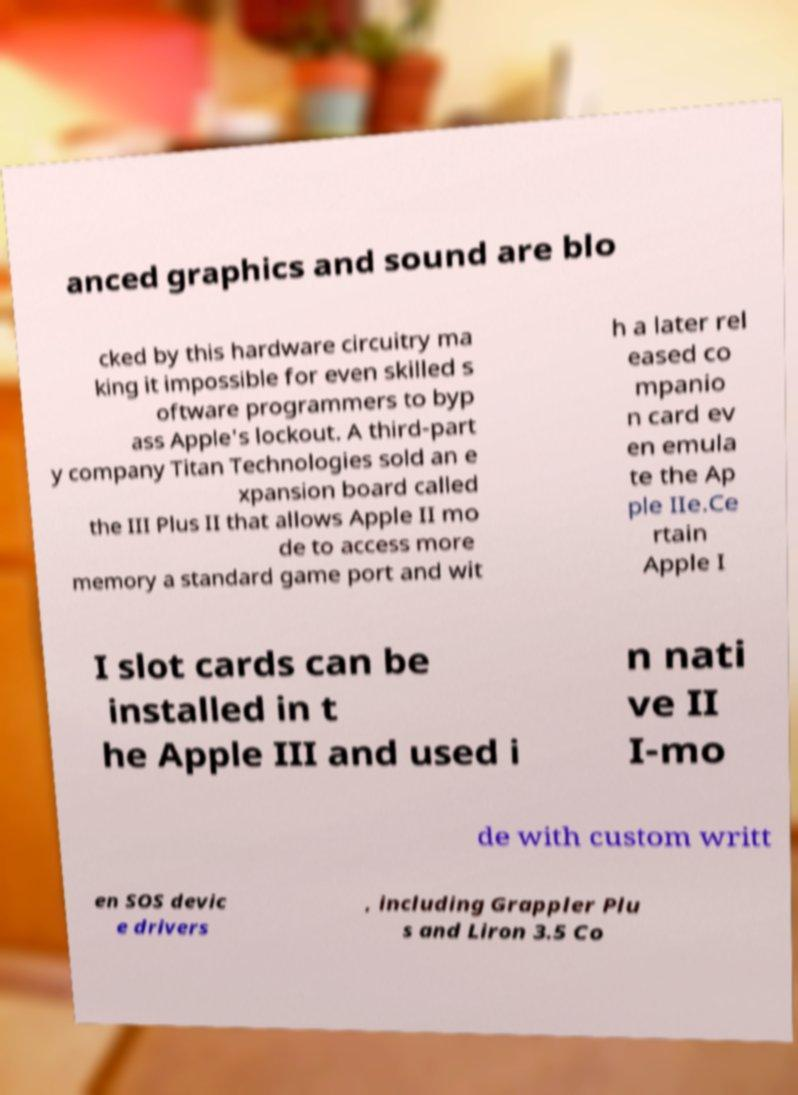Could you assist in decoding the text presented in this image and type it out clearly? anced graphics and sound are blo cked by this hardware circuitry ma king it impossible for even skilled s oftware programmers to byp ass Apple's lockout. A third-part y company Titan Technologies sold an e xpansion board called the III Plus II that allows Apple II mo de to access more memory a standard game port and wit h a later rel eased co mpanio n card ev en emula te the Ap ple IIe.Ce rtain Apple I I slot cards can be installed in t he Apple III and used i n nati ve II I-mo de with custom writt en SOS devic e drivers , including Grappler Plu s and Liron 3.5 Co 